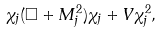<formula> <loc_0><loc_0><loc_500><loc_500>\chi _ { j } ( \Box + M _ { j } ^ { 2 } ) \chi _ { j } + V \chi _ { j } ^ { 2 } ,</formula> 